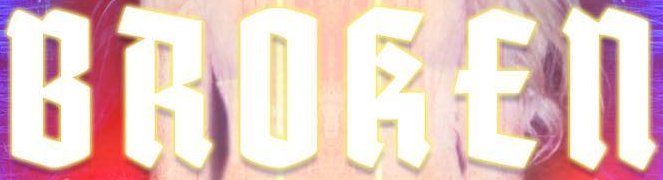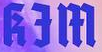Read the text content from these images in order, separated by a semicolon. BROKEn; kƎm 